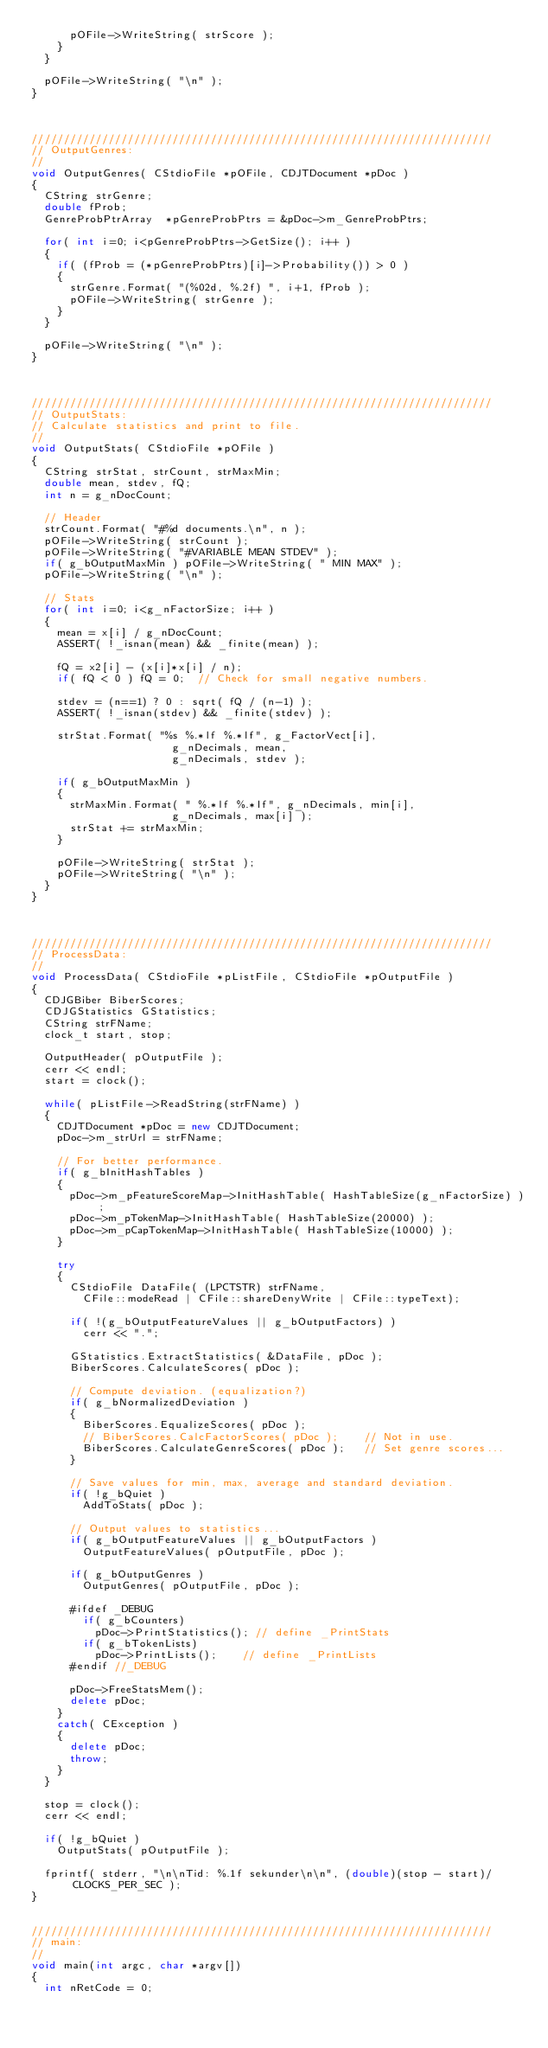Convert code to text. <code><loc_0><loc_0><loc_500><loc_500><_C++_>			pOFile->WriteString( strScore );
		}
	}
	
	pOFile->WriteString( "\n" );
}



////////////////////////////////////////////////////////////////////////
// OutputGenres:
//
void OutputGenres( CStdioFile *pOFile, CDJTDocument *pDoc )
{
	CString strGenre;
	double fProb;
	GenreProbPtrArray  *pGenreProbPtrs = &pDoc->m_GenreProbPtrs;

	for( int i=0; i<pGenreProbPtrs->GetSize(); i++ )
	{
		if( (fProb = (*pGenreProbPtrs)[i]->Probability()) > 0 )
		{
			strGenre.Format( "(%02d, %.2f) ", i+1, fProb );
			pOFile->WriteString( strGenre );
		}
	}
	
	pOFile->WriteString( "\n" );
}



////////////////////////////////////////////////////////////////////////
// OutputStats:
// Calculate statistics and print to file.
//
void OutputStats( CStdioFile *pOFile )
{
	CString strStat, strCount, strMaxMin;
	double mean, stdev, fQ;
	int n = g_nDocCount;

	// Header
	strCount.Format( "#%d documents.\n", n );
	pOFile->WriteString( strCount );
	pOFile->WriteString( "#VARIABLE MEAN STDEV" );
	if( g_bOutputMaxMin ) pOFile->WriteString( " MIN MAX" );
	pOFile->WriteString( "\n" );

	// Stats
	for( int i=0; i<g_nFactorSize; i++ )
	{
		mean = x[i] / g_nDocCount;
		ASSERT( !_isnan(mean) && _finite(mean) );

		fQ = x2[i] - (x[i]*x[i] / n);
		if( fQ < 0 ) fQ = 0;	// Check for small negative numbers.

		stdev = (n==1) ? 0 : sqrt( fQ / (n-1) );
		ASSERT( !_isnan(stdev) && _finite(stdev) );

		strStat.Format( "%s %.*lf %.*lf", g_FactorVect[i],  
											g_nDecimals, mean, 
											g_nDecimals, stdev );

		if( g_bOutputMaxMin )
		{
			strMaxMin.Format( " %.*lf %.*lf", g_nDecimals, min[i],
											g_nDecimals, max[i] );
			strStat += strMaxMin;
		}

		pOFile->WriteString( strStat );
		pOFile->WriteString( "\n" );
	}
}



////////////////////////////////////////////////////////////////////////
// ProcessData:
//
void ProcessData( CStdioFile *pListFile, CStdioFile *pOutputFile )
{
	CDJGBiber BiberScores;
	CDJGStatistics GStatistics;
	CString strFName;
	clock_t start, stop;

	OutputHeader( pOutputFile );
	cerr << endl;
	start = clock();

	while( pListFile->ReadString(strFName) )
	{
		CDJTDocument *pDoc = new CDJTDocument;
		pDoc->m_strUrl = strFName;

		// For better performance.
		if( g_bInitHashTables )
		{
			pDoc->m_pFeatureScoreMap->InitHashTable( HashTableSize(g_nFactorSize) );
			pDoc->m_pTokenMap->InitHashTable( HashTableSize(20000) );
			pDoc->m_pCapTokenMap->InitHashTable( HashTableSize(10000) );
		}

		try
		{
			CStdioFile DataFile( (LPCTSTR) strFName, 
				CFile::modeRead | CFile::shareDenyWrite | CFile::typeText);

			if( !(g_bOutputFeatureValues || g_bOutputFactors) )
				cerr << ".";

			GStatistics.ExtractStatistics( &DataFile, pDoc );
			BiberScores.CalculateScores( pDoc );
	
			// Compute deviation. (equalization?)
			if( g_bNormalizedDeviation )
			{
				BiberScores.EqualizeScores( pDoc );
				// BiberScores.CalcFactorScores( pDoc );		// Not in use.
				BiberScores.CalculateGenreScores( pDoc );		// Set genre scores...
			}
	
			// Save values for min, max, average and standard deviation.
			if( !g_bQuiet )
				AddToStats( pDoc );

			// Output values to statistics...
			if( g_bOutputFeatureValues || g_bOutputFactors )
				OutputFeatureValues( pOutputFile, pDoc );

			if( g_bOutputGenres )
				OutputGenres( pOutputFile, pDoc );
	
			#ifdef _DEBUG
				if( g_bCounters) 
					pDoc->PrintStatistics(); // define _PrintStats
				if( g_bTokenLists) 
					pDoc->PrintLists();		 // define _PrintLists
			#endif //_DEBUG

			pDoc->FreeStatsMem();
			delete pDoc;
		}
		catch( CException )
		{
			delete pDoc;
			throw;
		}
	}

	stop = clock();
	cerr << endl;

	if( !g_bQuiet )
		OutputStats( pOutputFile );

	fprintf( stderr, "\n\nTid: %.1f sekunder\n\n", (double)(stop - start)/CLOCKS_PER_SEC );
}


////////////////////////////////////////////////////////////////////////
// main:
//
void main(int argc, char *argv[])
{
	int nRetCode = 0;</code> 